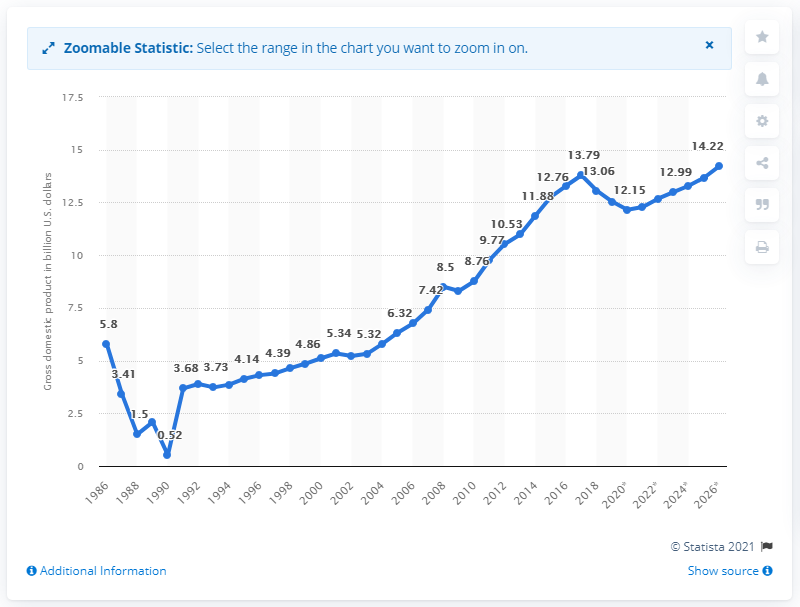Draw attention to some important aspects in this diagram. In 2019, Nicaragua's gross domestic product (GDP) was 12.54. 